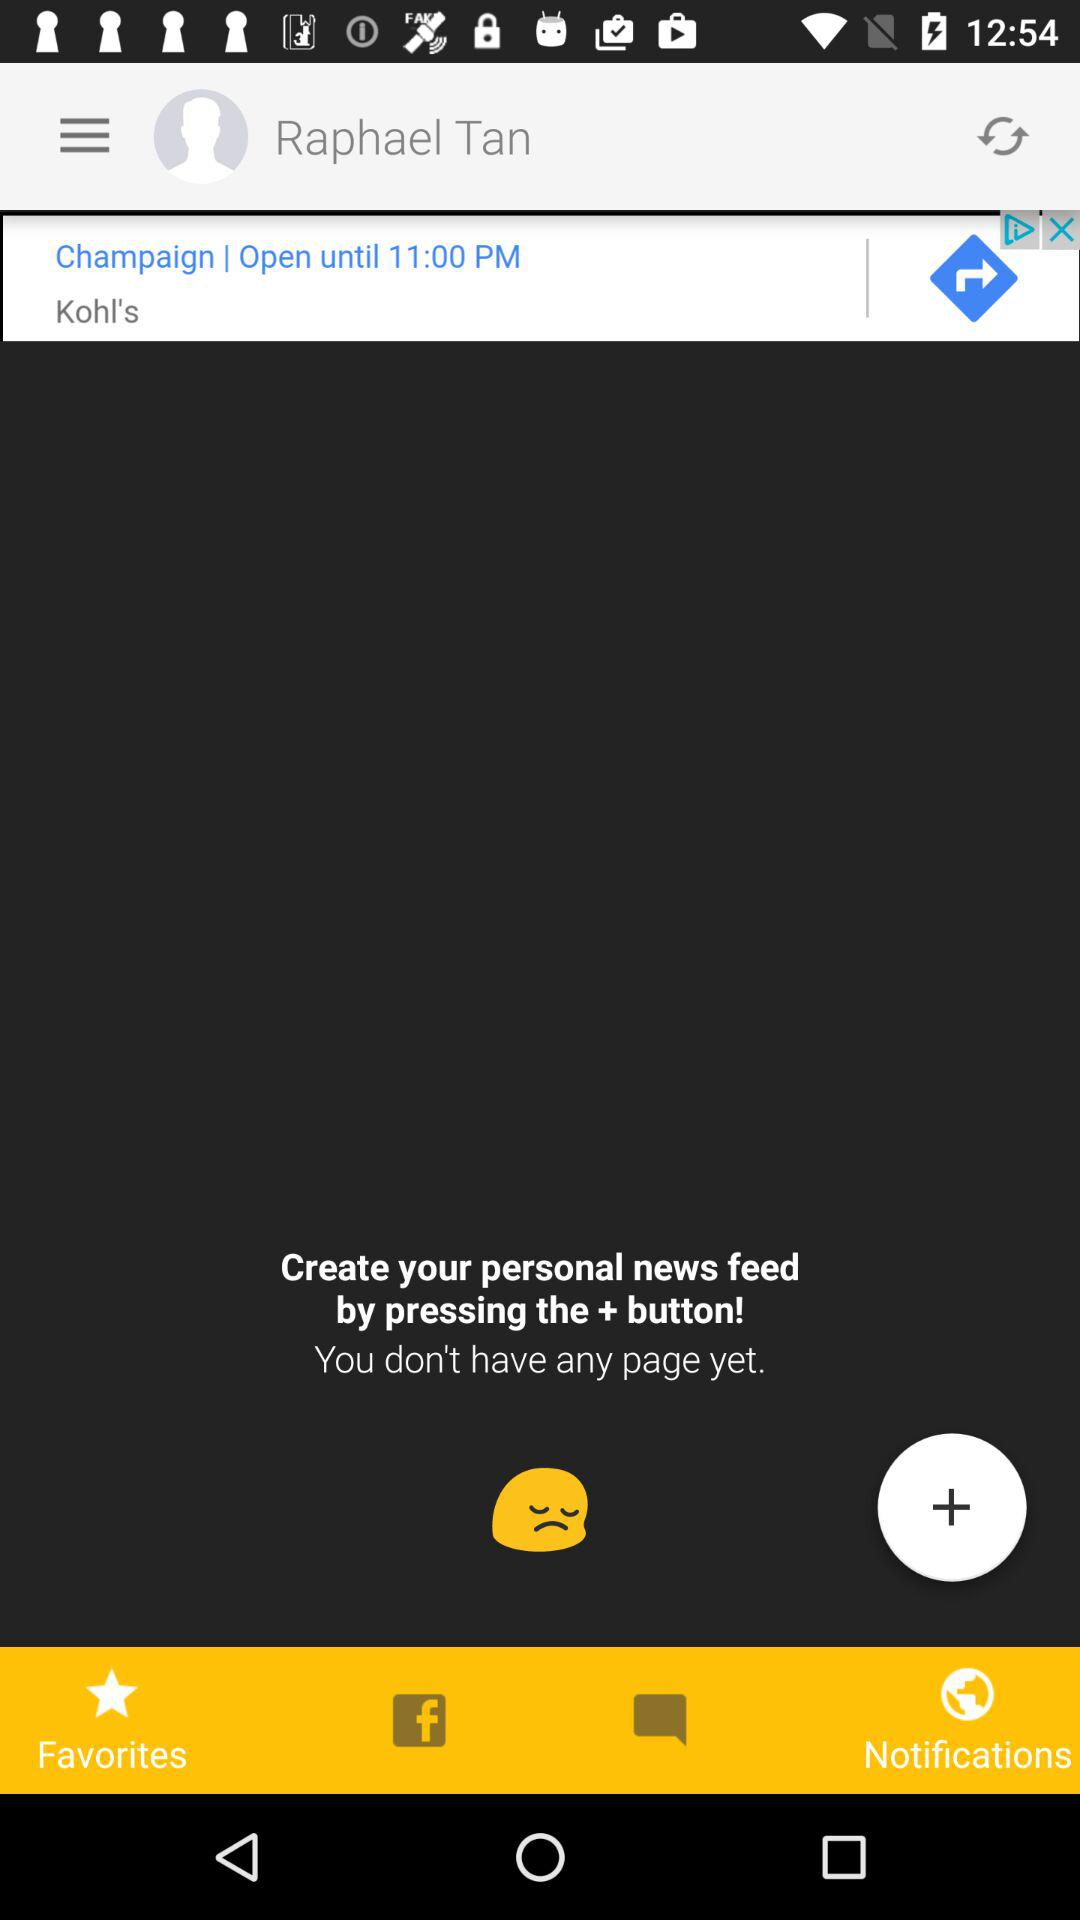What's the user name? The user name is Raphael Tan. 